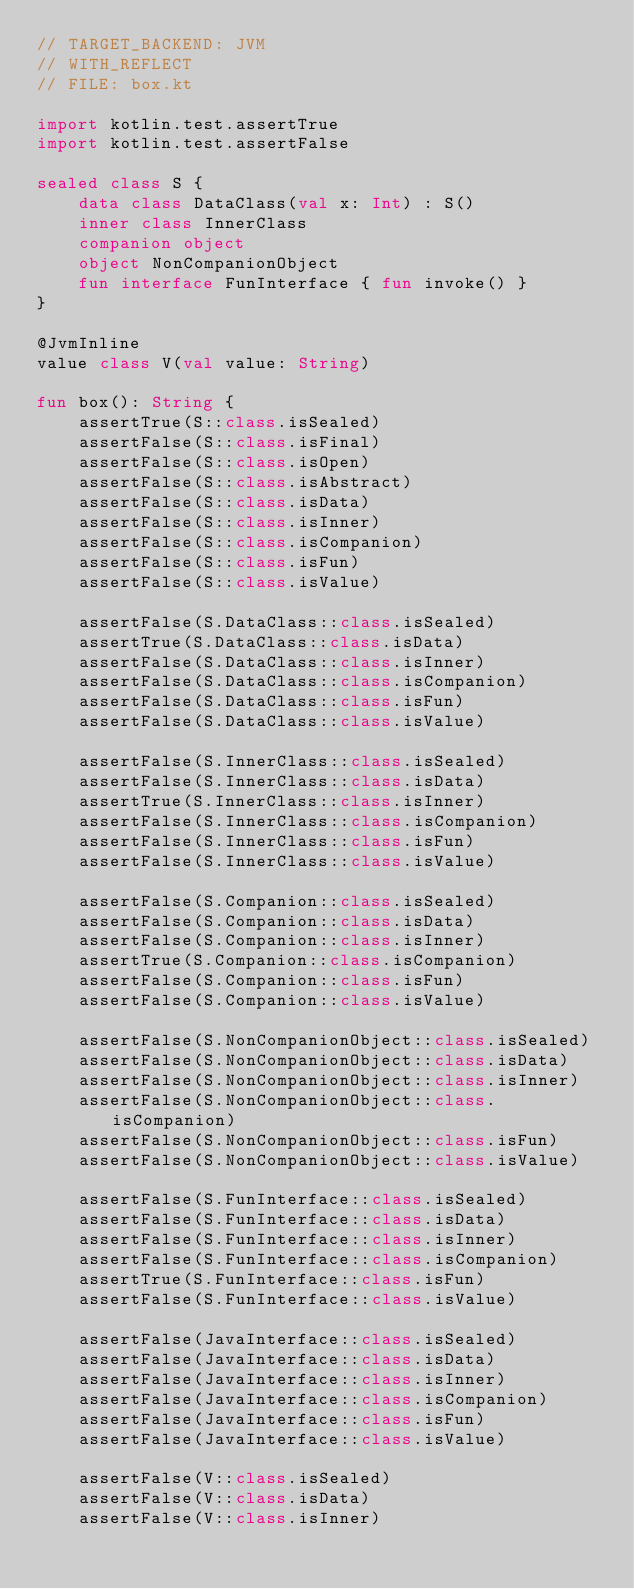<code> <loc_0><loc_0><loc_500><loc_500><_Kotlin_>// TARGET_BACKEND: JVM
// WITH_REFLECT
// FILE: box.kt

import kotlin.test.assertTrue
import kotlin.test.assertFalse

sealed class S {
    data class DataClass(val x: Int) : S()
    inner class InnerClass
    companion object
    object NonCompanionObject
    fun interface FunInterface { fun invoke() }
}

@JvmInline
value class V(val value: String)

fun box(): String {
    assertTrue(S::class.isSealed)
    assertFalse(S::class.isFinal)
    assertFalse(S::class.isOpen)
    assertFalse(S::class.isAbstract)
    assertFalse(S::class.isData)
    assertFalse(S::class.isInner)
    assertFalse(S::class.isCompanion)
    assertFalse(S::class.isFun)
    assertFalse(S::class.isValue)

    assertFalse(S.DataClass::class.isSealed)
    assertTrue(S.DataClass::class.isData)
    assertFalse(S.DataClass::class.isInner)
    assertFalse(S.DataClass::class.isCompanion)
    assertFalse(S.DataClass::class.isFun)
    assertFalse(S.DataClass::class.isValue)

    assertFalse(S.InnerClass::class.isSealed)
    assertFalse(S.InnerClass::class.isData)
    assertTrue(S.InnerClass::class.isInner)
    assertFalse(S.InnerClass::class.isCompanion)
    assertFalse(S.InnerClass::class.isFun)
    assertFalse(S.InnerClass::class.isValue)

    assertFalse(S.Companion::class.isSealed)
    assertFalse(S.Companion::class.isData)
    assertFalse(S.Companion::class.isInner)
    assertTrue(S.Companion::class.isCompanion)
    assertFalse(S.Companion::class.isFun)
    assertFalse(S.Companion::class.isValue)

    assertFalse(S.NonCompanionObject::class.isSealed)
    assertFalse(S.NonCompanionObject::class.isData)
    assertFalse(S.NonCompanionObject::class.isInner)
    assertFalse(S.NonCompanionObject::class.isCompanion)
    assertFalse(S.NonCompanionObject::class.isFun)
    assertFalse(S.NonCompanionObject::class.isValue)

    assertFalse(S.FunInterface::class.isSealed)
    assertFalse(S.FunInterface::class.isData)
    assertFalse(S.FunInterface::class.isInner)
    assertFalse(S.FunInterface::class.isCompanion)
    assertTrue(S.FunInterface::class.isFun)
    assertFalse(S.FunInterface::class.isValue)

    assertFalse(JavaInterface::class.isSealed)
    assertFalse(JavaInterface::class.isData)
    assertFalse(JavaInterface::class.isInner)
    assertFalse(JavaInterface::class.isCompanion)
    assertFalse(JavaInterface::class.isFun)
    assertFalse(JavaInterface::class.isValue)

    assertFalse(V::class.isSealed)
    assertFalse(V::class.isData)
    assertFalse(V::class.isInner)</code> 